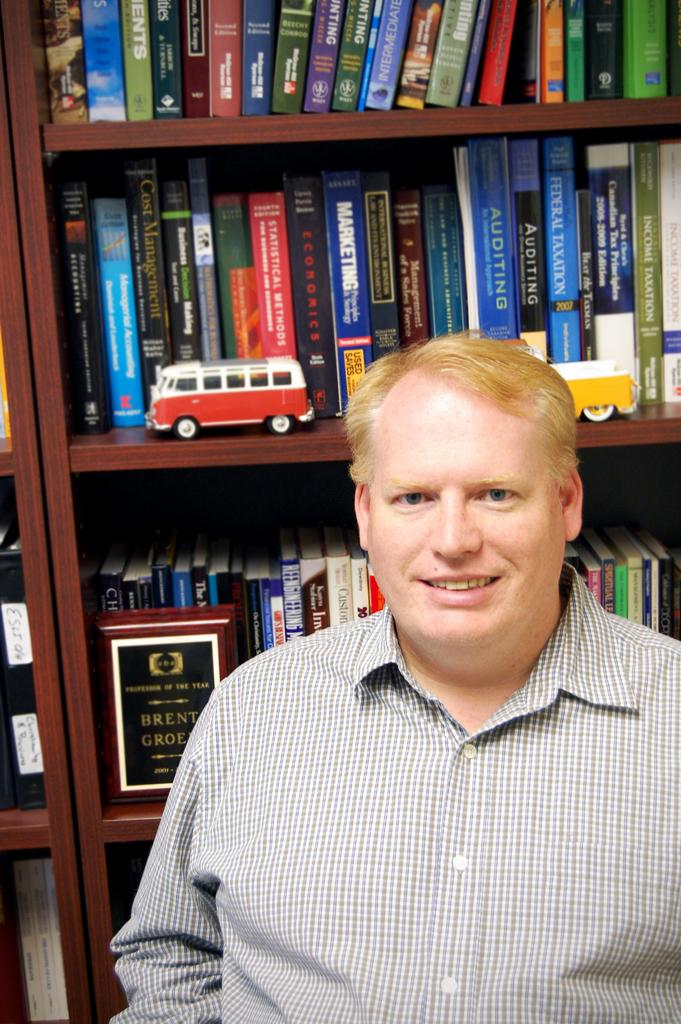Who is the main subject in the image? There is a man in the middle of the image. What is the man doing in the image? The man is laughing. What can be seen in the background of the image? There are racks in the background of the image. What items are stored in the racks? There are books and two toys in the racks. What type of voyage is the man planning in the image? There is no indication of a voyage in the image; the man is simply laughing. 